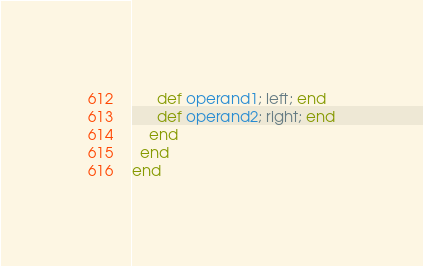Convert code to text. <code><loc_0><loc_0><loc_500><loc_500><_Ruby_>      def operand1; left; end
      def operand2; right; end
    end
  end
end
</code> 